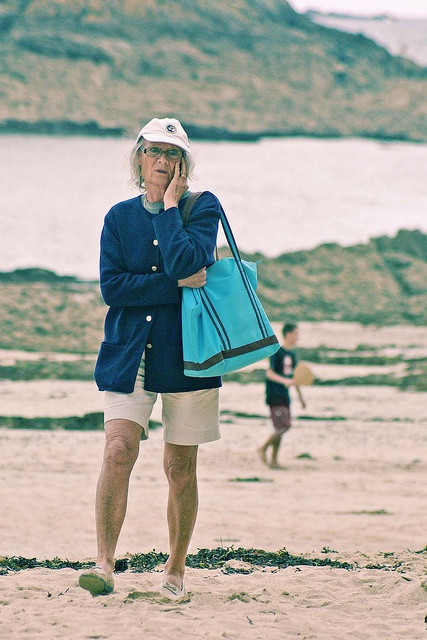Describe the objects in this image and their specific colors. I can see people in teal, darkblue, navy, blue, and darkgray tones, handbag in teal and lightblue tones, people in teal, gray, black, darkgray, and tan tones, and cell phone in teal, black, darkgreen, and gray tones in this image. 